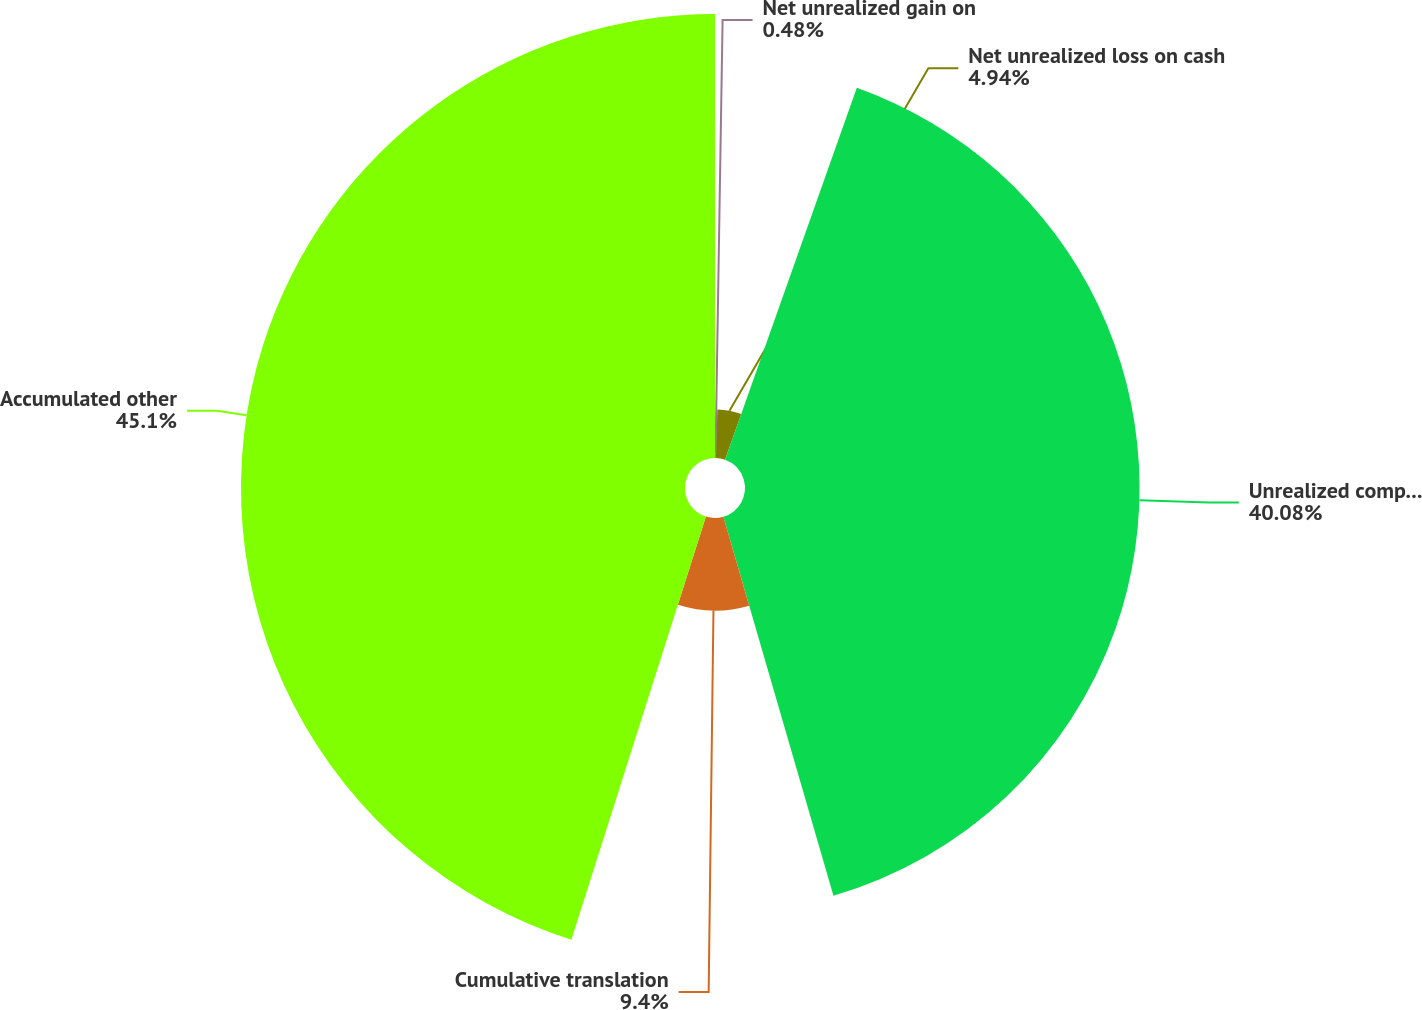<chart> <loc_0><loc_0><loc_500><loc_500><pie_chart><fcel>Net unrealized gain on<fcel>Net unrealized loss on cash<fcel>Unrealized components of<fcel>Cumulative translation<fcel>Accumulated other<nl><fcel>0.48%<fcel>4.94%<fcel>40.08%<fcel>9.4%<fcel>45.1%<nl></chart> 